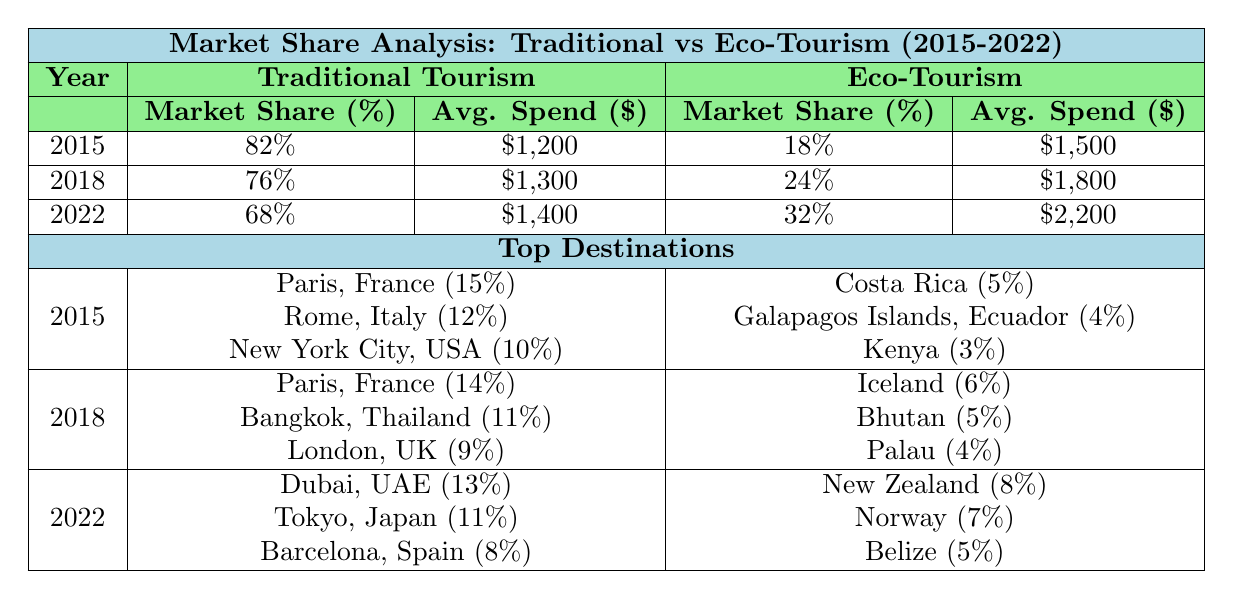What was the market share of traditional tourism in 2022? According to the table, the market share of traditional tourism in 2022 is listed as 68%.
Answer: 68% Which eco-tourism destination had the highest share in 2022? In 2022, the highest share for an eco-tourism destination was for New Zealand at 8%.
Answer: New Zealand What is the average spend per tourist for traditional tourism in 2018? The table shows the average spend per tourist for traditional tourism in 2018 as $1,300.
Answer: $1,300 How much did the market share of traditional tourism decrease from 2015 to 2022? In 2015, traditional tourism had a market share of 82%, and by 2022 it decreased to 68%. The difference is 82% - 68% = 14%.
Answer: 14% What was the average market share of eco-tourism from 2015 to 2022? The market shares for eco-tourism from 2015 to 2022 are 18%, 24%, and 32%. The total is 18% + 24% + 32% = 74%, and the average is 74% / 3 = 24.67%.
Answer: 24.67% Which traditional tourism destination had the second-highest market share in 2018? In 2018, the traditional tourism destinations listed are Paris, France (14%), Bangkok, Thailand (11%), and London, UK (9%). The second-highest is Bangkok with 11%.
Answer: Bangkok, Thailand Did eco-tourism's market share increase every year from 2015 to 2022? In 2015, eco-tourism's market share was 18%, in 2018 it increased to 24%, and in 2022 it rose further to 32%. Therefore, eco-tourism's market share increased each year.
Answer: Yes What was the difference in average spend per tourist between traditional and eco-tourism in 2022? In 2022, traditional tourism had an average spend of $1,400, while eco-tourism had $2,200. The difference is $2,200 - $1,400 = $800.
Answer: $800 Which year saw the largest increase in market share for eco-tourism? Eco-tourism's market share increased from 18% in 2015 to 24% in 2018 (an increase of 6%) and from 24% to 32% in 2022 (an increase of 8%). The largest increase was from 2018 to 2022.
Answer: 2022 What are the top three destinations for traditional tourism in 2015? The top three traditional tourism destinations in 2015 are Paris, France (15%), Rome, Italy (12%), and New York City, USA (10%).
Answer: Paris, Rome, and New York City How does the average spend per tourist in traditional tourism compare to eco-tourism in 2015? In 2015, traditional tourism's average spend was $1,200 while eco-tourism's was $1,500. To compare, eco-tourism had a higher spend by $1,500 - $1,200 = $300.
Answer: $300 higher for eco-tourism 